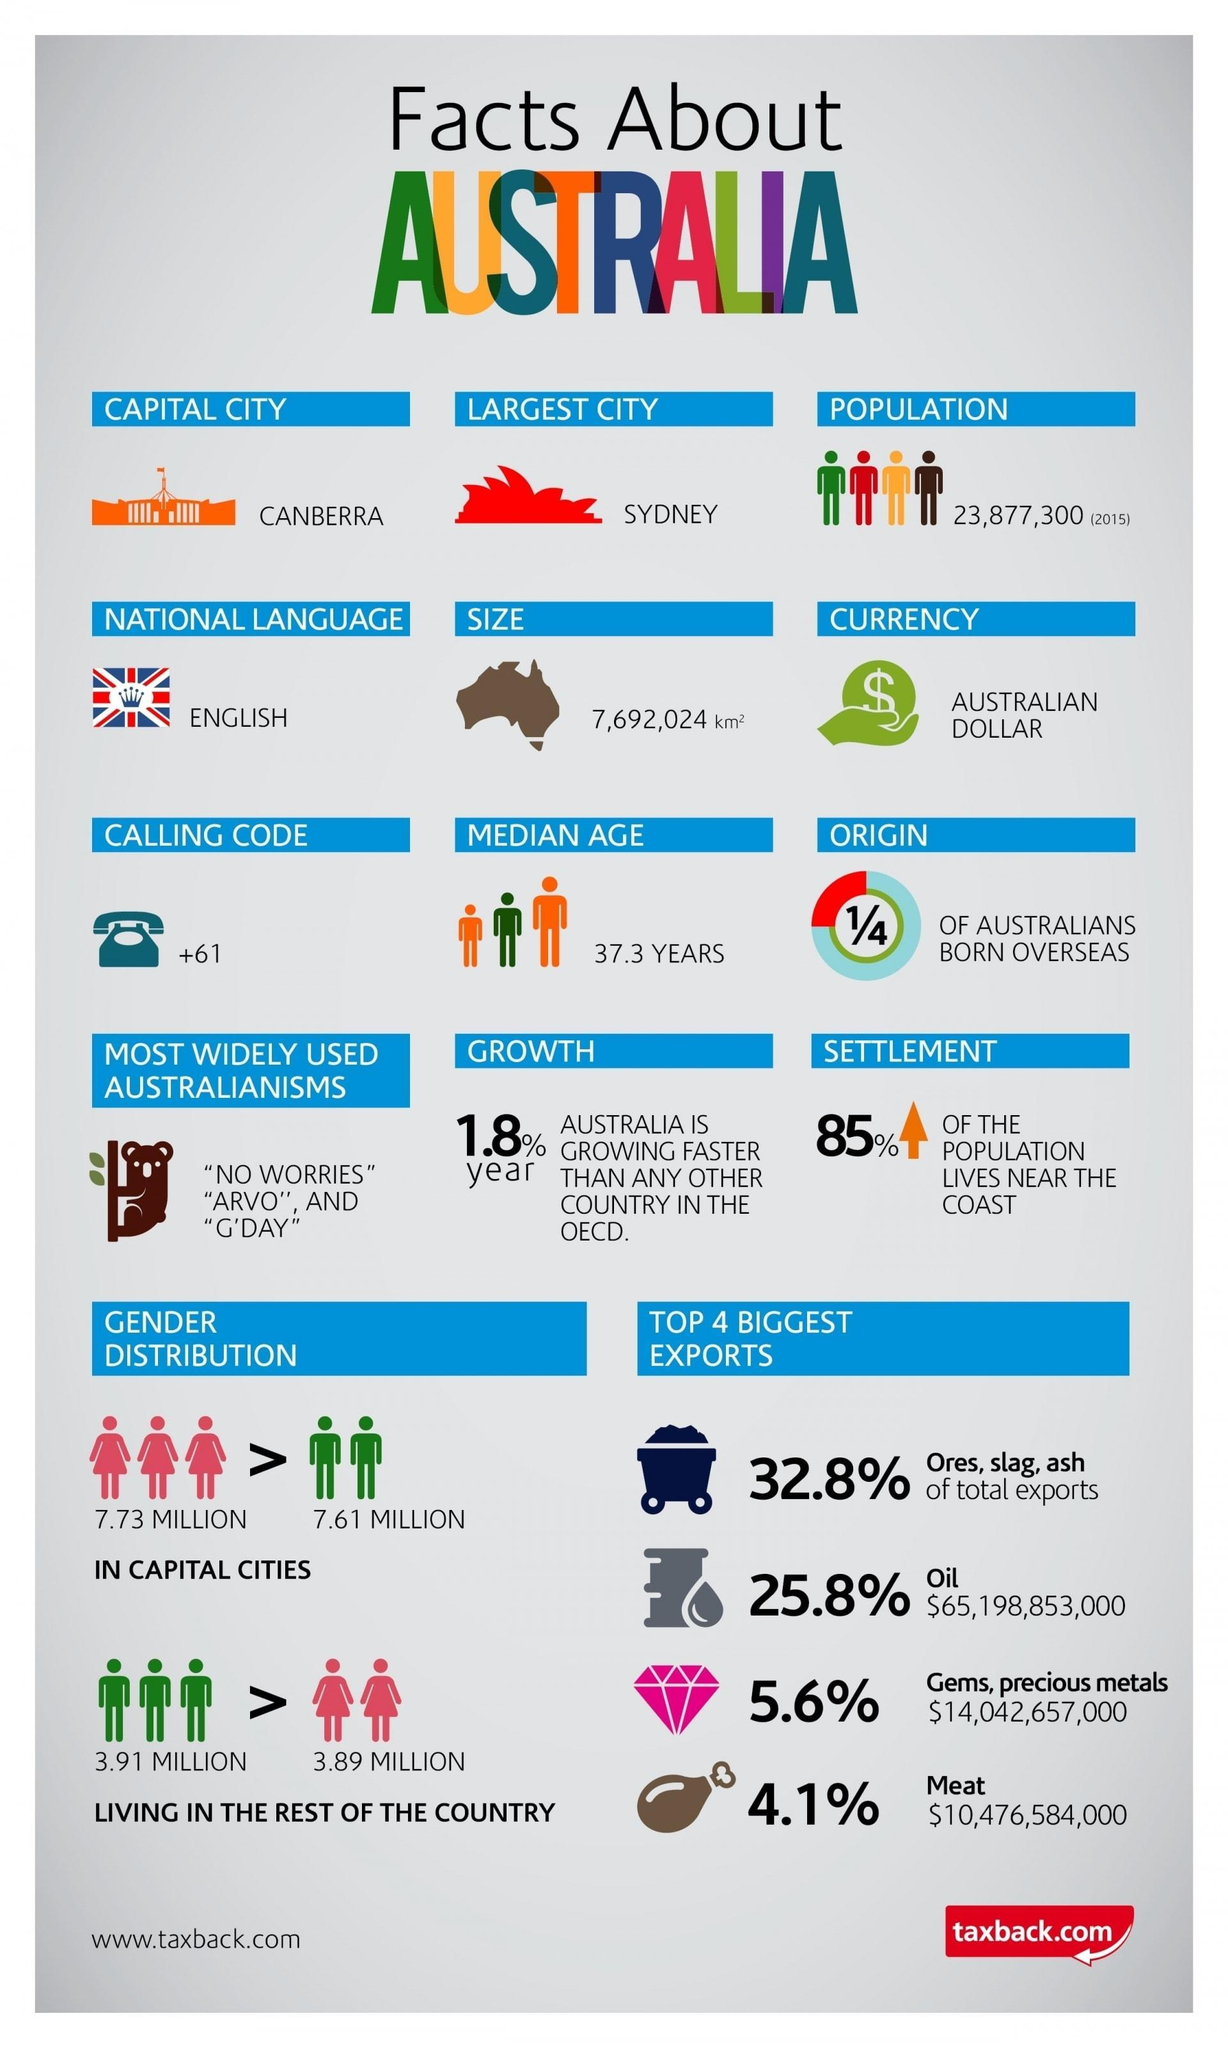what is the area of Australia
Answer the question with a short phrase. 7,692,024 km2 How much higher in millions is the population of females than males in capital cities 0.12 The top 4 biggest exports covers how much share of the market in % 68.3 What % of export market is covered my meat and gems, precious metals 9.7 Which is the largest city in Australia Sydney What % of the population live away from the coast 15 How much higher in millions is the population of males than females in rest of the country 0.02 